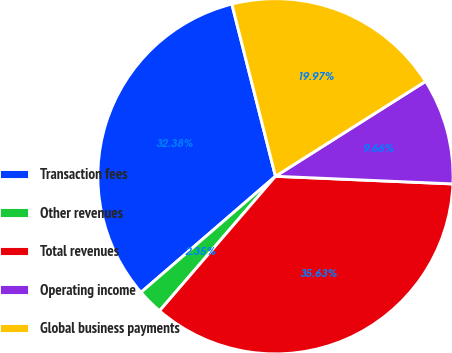Convert chart to OTSL. <chart><loc_0><loc_0><loc_500><loc_500><pie_chart><fcel>Transaction fees<fcel>Other revenues<fcel>Total revenues<fcel>Operating income<fcel>Global business payments<nl><fcel>32.38%<fcel>2.35%<fcel>35.63%<fcel>9.66%<fcel>19.97%<nl></chart> 